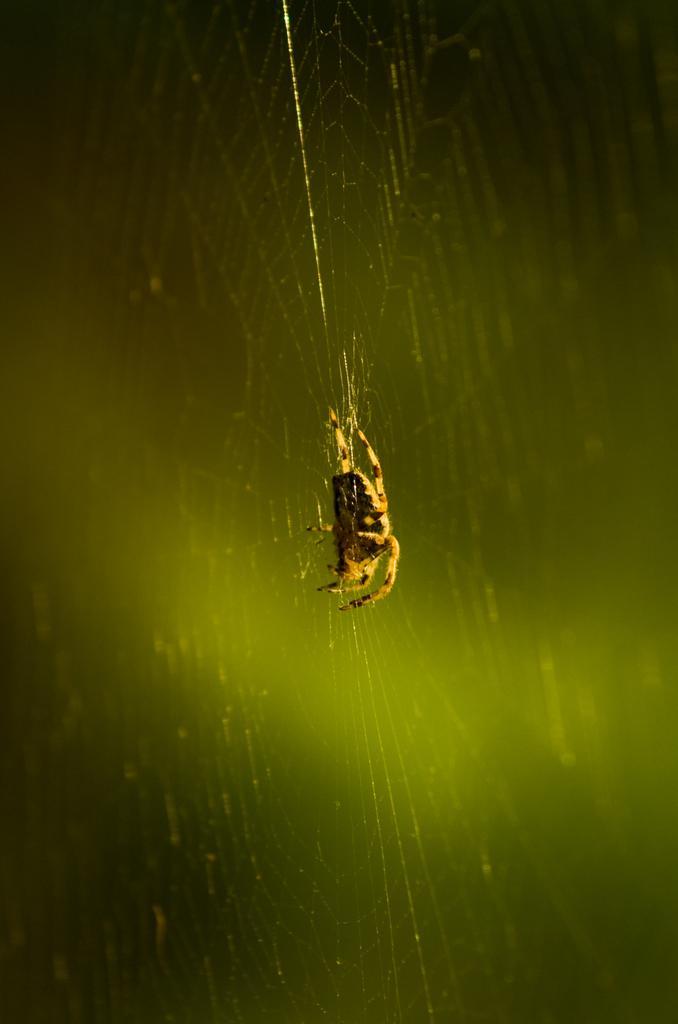Can you describe this image briefly? In this image, I can see a spider on the spider web. The background looks green in color. 